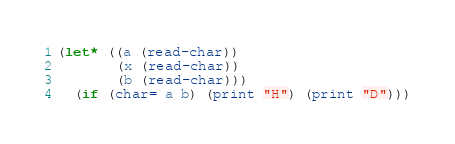<code> <loc_0><loc_0><loc_500><loc_500><_Lisp_>(let* ((a (read-char))
       (x (read-char))
       (b (read-char)))
  (if (char= a b) (print "H") (print "D")))</code> 